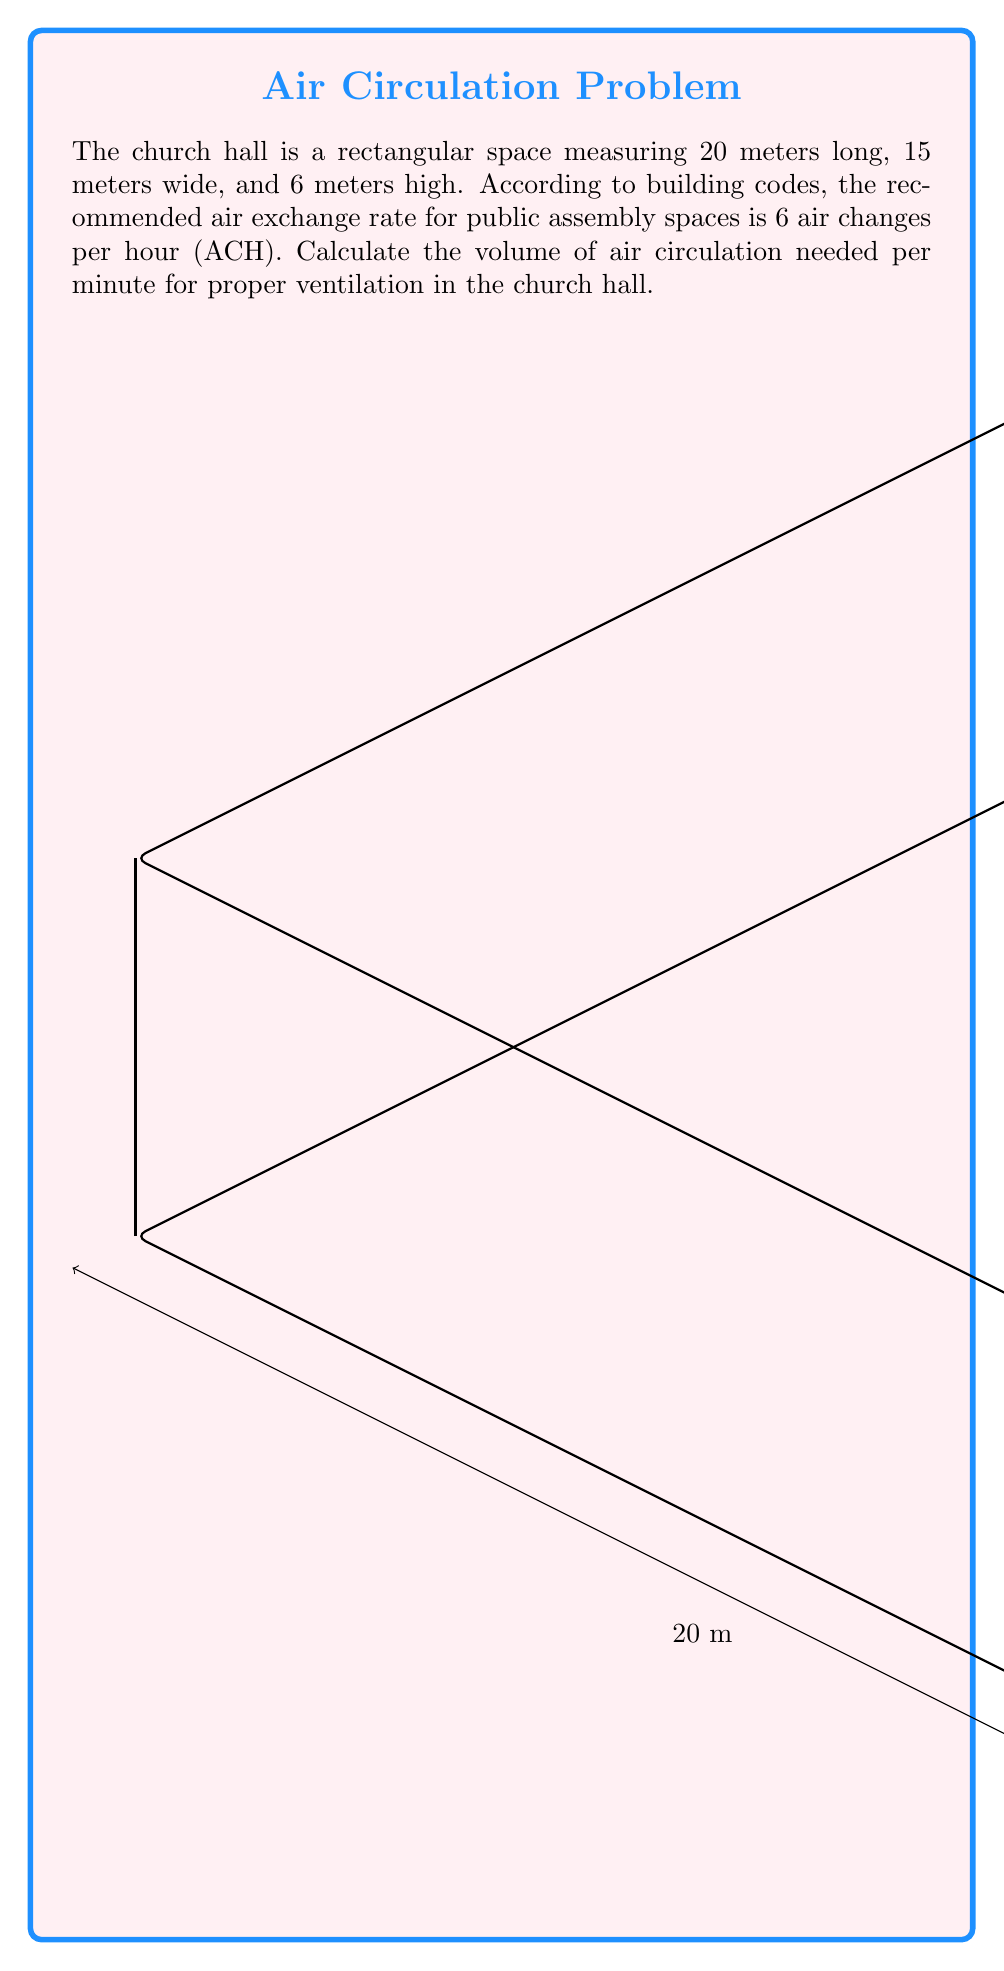Show me your answer to this math problem. Let's approach this step-by-step:

1) First, calculate the volume of the church hall:
   $$V = length \times width \times height$$
   $$V = 20 \text{ m} \times 15 \text{ m} \times 6 \text{ m} = 1800 \text{ m}^3$$

2) The air exchange rate is 6 ACH, meaning the entire volume of air needs to be replaced 6 times per hour.

3) Calculate the volume of air that needs to be circulated per hour:
   $$V_{hour} = 1800 \text{ m}^3 \times 6 = 10800 \text{ m}^3/\text{hour}$$

4) Convert this to volume per minute:
   $$V_{minute} = \frac{10800 \text{ m}^3/\text{hour}}{60 \text{ minutes/hour}} = 180 \text{ m}^3/\text{minute}$$

Therefore, the volume of air circulation needed per minute for proper ventilation is 180 cubic meters per minute.
Answer: $180 \text{ m}^3/\text{minute}$ 